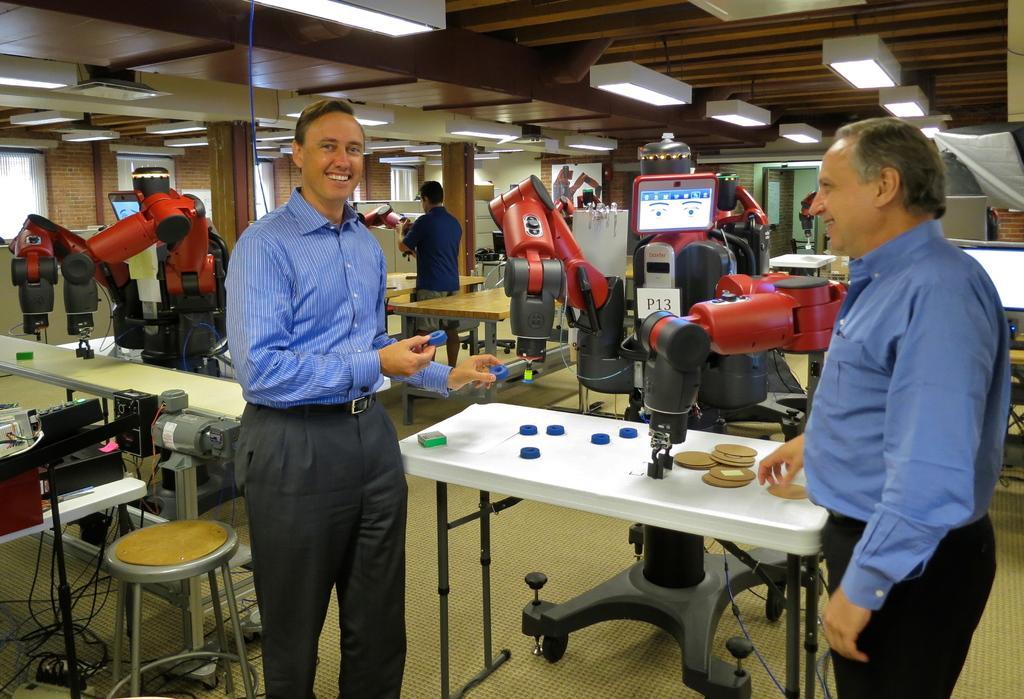Please provide a concise description of this image. In the foreground of the picture there are people, machine, table, cards and some other objects. On the left tables, stool, cables, machines. In the background there are tables, machine, person and other objects. At the top there are lights in the ceiling. In the background there are windows, mirrors and door. 